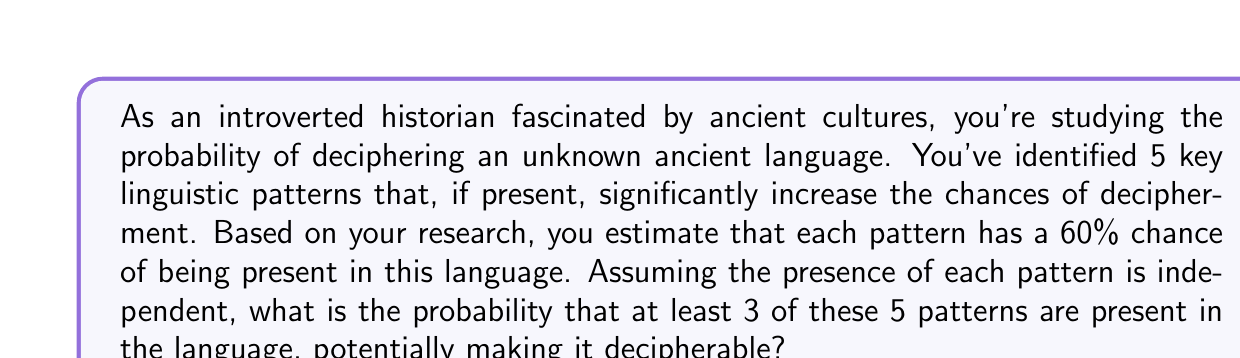Can you solve this math problem? Let's approach this step-by-step using the binomial probability distribution:

1) We can model this as a binomial distribution where:
   $n = 5$ (total number of patterns)
   $p = 0.60$ (probability of each pattern being present)
   $q = 1 - p = 0.40$ (probability of each pattern not being present)

2) We want the probability of at least 3 patterns being present. This is equivalent to the sum of probabilities of exactly 3, 4, or 5 patterns being present.

3) The probability of exactly $k$ successes in $n$ trials is given by the binomial probability formula:

   $P(X = k) = \binom{n}{k} p^k q^{n-k}$

4) Let's calculate each probability:

   For 3 patterns: $P(X = 3) = \binom{5}{3} (0.60)^3 (0.40)^2 = 10 \cdot 0.216 \cdot 0.16 = 0.3456$
   
   For 4 patterns: $P(X = 4) = \binom{5}{4} (0.60)^4 (0.40)^1 = 5 \cdot 0.1296 \cdot 0.40 = 0.2592$
   
   For 5 patterns: $P(X = 5) = \binom{5}{5} (0.60)^5 (0.40)^0 = 1 \cdot 0.07776 \cdot 1 = 0.07776$

5) The total probability is the sum of these individual probabilities:

   $P(X \geq 3) = P(X = 3) + P(X = 4) + P(X = 5)$
                $= 0.3456 + 0.2592 + 0.07776$
                $= 0.68256$

6) Therefore, the probability of at least 3 patterns being present is approximately 0.6826 or 68.26%.
Answer: The probability that at least 3 of the 5 linguistic patterns are present in the ancient language is approximately $0.6826$ or $68.26\%$. 